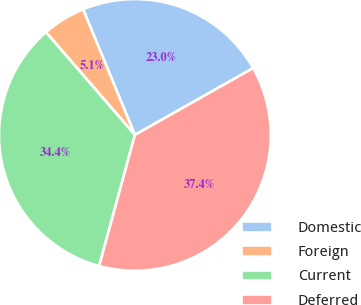<chart> <loc_0><loc_0><loc_500><loc_500><pie_chart><fcel>Domestic<fcel>Foreign<fcel>Current<fcel>Deferred<nl><fcel>23.04%<fcel>5.13%<fcel>34.41%<fcel>37.42%<nl></chart> 